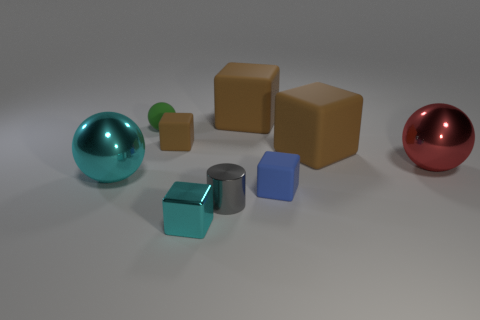Subtract all metal spheres. How many spheres are left? 1 Subtract all gray cylinders. How many brown blocks are left? 3 Subtract all cyan cubes. How many cubes are left? 4 Subtract all cylinders. How many objects are left? 8 Add 2 cyan cubes. How many cyan cubes exist? 3 Subtract 0 red cylinders. How many objects are left? 9 Subtract all yellow cubes. Subtract all brown balls. How many cubes are left? 5 Subtract all tiny green matte things. Subtract all big red shiny objects. How many objects are left? 7 Add 7 brown rubber objects. How many brown rubber objects are left? 10 